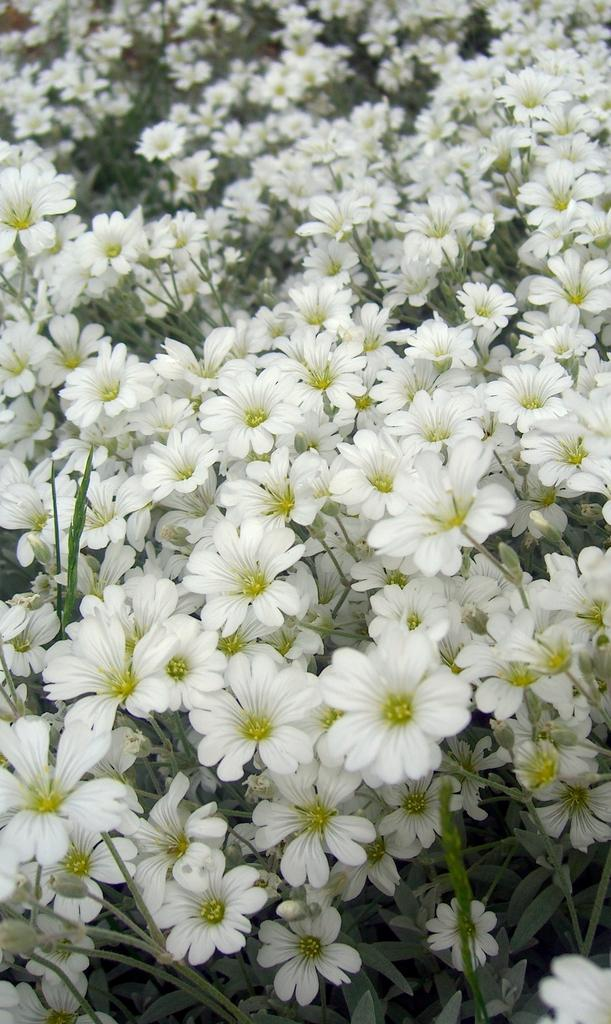What type of flowers can be seen in the image? There are many white flowers in the image. Can you describe the color of the flowers? The flowers are white. What type of pleasure can be seen in the image? There is no reference to pleasure in the image; it features white flowers. 